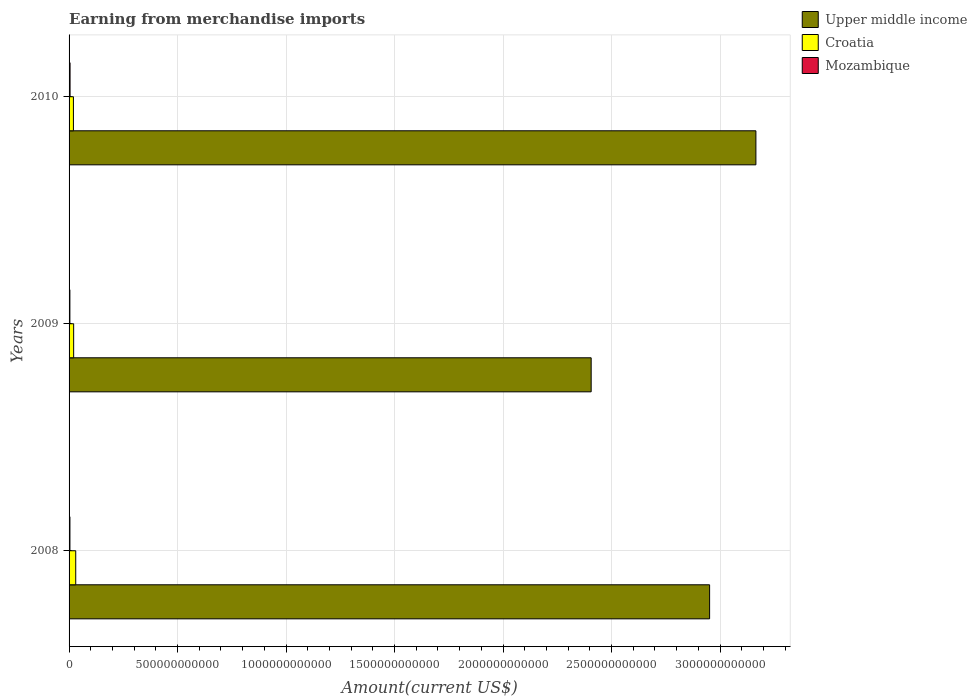How many bars are there on the 1st tick from the bottom?
Your answer should be very brief. 3. What is the amount earned from merchandise imports in Upper middle income in 2008?
Provide a succinct answer. 2.95e+12. Across all years, what is the maximum amount earned from merchandise imports in Mozambique?
Keep it short and to the point. 4.60e+09. Across all years, what is the minimum amount earned from merchandise imports in Upper middle income?
Ensure brevity in your answer.  2.41e+12. In which year was the amount earned from merchandise imports in Mozambique minimum?
Offer a very short reply. 2009. What is the total amount earned from merchandise imports in Croatia in the graph?
Offer a very short reply. 7.19e+1. What is the difference between the amount earned from merchandise imports in Upper middle income in 2008 and that in 2009?
Keep it short and to the point. 5.46e+11. What is the difference between the amount earned from merchandise imports in Upper middle income in 2010 and the amount earned from merchandise imports in Mozambique in 2008?
Offer a terse response. 3.16e+12. What is the average amount earned from merchandise imports in Croatia per year?
Provide a succinct answer. 2.40e+1. In the year 2010, what is the difference between the amount earned from merchandise imports in Upper middle income and amount earned from merchandise imports in Mozambique?
Keep it short and to the point. 3.16e+12. What is the ratio of the amount earned from merchandise imports in Upper middle income in 2008 to that in 2010?
Make the answer very short. 0.93. Is the amount earned from merchandise imports in Croatia in 2008 less than that in 2010?
Offer a terse response. No. What is the difference between the highest and the second highest amount earned from merchandise imports in Upper middle income?
Provide a short and direct response. 2.13e+11. What is the difference between the highest and the lowest amount earned from merchandise imports in Upper middle income?
Keep it short and to the point. 7.59e+11. In how many years, is the amount earned from merchandise imports in Croatia greater than the average amount earned from merchandise imports in Croatia taken over all years?
Offer a terse response. 1. What does the 1st bar from the top in 2009 represents?
Give a very brief answer. Mozambique. What does the 2nd bar from the bottom in 2010 represents?
Offer a very short reply. Croatia. Are all the bars in the graph horizontal?
Your response must be concise. Yes. How many years are there in the graph?
Provide a short and direct response. 3. What is the difference between two consecutive major ticks on the X-axis?
Give a very brief answer. 5.00e+11. Does the graph contain any zero values?
Provide a short and direct response. No. Does the graph contain grids?
Your response must be concise. Yes. Where does the legend appear in the graph?
Your answer should be very brief. Top right. How many legend labels are there?
Offer a terse response. 3. How are the legend labels stacked?
Your answer should be compact. Vertical. What is the title of the graph?
Make the answer very short. Earning from merchandise imports. Does "Channel Islands" appear as one of the legend labels in the graph?
Provide a short and direct response. No. What is the label or title of the X-axis?
Your answer should be compact. Amount(current US$). What is the Amount(current US$) of Upper middle income in 2008?
Ensure brevity in your answer.  2.95e+12. What is the Amount(current US$) in Croatia in 2008?
Provide a succinct answer. 3.07e+1. What is the Amount(current US$) in Mozambique in 2008?
Provide a succinct answer. 4.01e+09. What is the Amount(current US$) in Upper middle income in 2009?
Give a very brief answer. 2.41e+12. What is the Amount(current US$) in Croatia in 2009?
Your response must be concise. 2.11e+1. What is the Amount(current US$) of Mozambique in 2009?
Your answer should be very brief. 3.76e+09. What is the Amount(current US$) in Upper middle income in 2010?
Give a very brief answer. 3.17e+12. What is the Amount(current US$) of Croatia in 2010?
Your response must be concise. 2.01e+1. What is the Amount(current US$) in Mozambique in 2010?
Offer a terse response. 4.60e+09. Across all years, what is the maximum Amount(current US$) of Upper middle income?
Provide a succinct answer. 3.17e+12. Across all years, what is the maximum Amount(current US$) of Croatia?
Your answer should be compact. 3.07e+1. Across all years, what is the maximum Amount(current US$) in Mozambique?
Offer a very short reply. 4.60e+09. Across all years, what is the minimum Amount(current US$) of Upper middle income?
Ensure brevity in your answer.  2.41e+12. Across all years, what is the minimum Amount(current US$) of Croatia?
Offer a terse response. 2.01e+1. Across all years, what is the minimum Amount(current US$) of Mozambique?
Offer a terse response. 3.76e+09. What is the total Amount(current US$) of Upper middle income in the graph?
Your answer should be very brief. 8.52e+12. What is the total Amount(current US$) of Croatia in the graph?
Give a very brief answer. 7.19e+1. What is the total Amount(current US$) in Mozambique in the graph?
Provide a succinct answer. 1.24e+1. What is the difference between the Amount(current US$) in Upper middle income in 2008 and that in 2009?
Your response must be concise. 5.46e+11. What is the difference between the Amount(current US$) of Croatia in 2008 and that in 2009?
Make the answer very short. 9.61e+09. What is the difference between the Amount(current US$) of Mozambique in 2008 and that in 2009?
Make the answer very short. 2.44e+08. What is the difference between the Amount(current US$) in Upper middle income in 2008 and that in 2010?
Your answer should be very brief. -2.13e+11. What is the difference between the Amount(current US$) in Croatia in 2008 and that in 2010?
Your answer should be very brief. 1.07e+1. What is the difference between the Amount(current US$) of Mozambique in 2008 and that in 2010?
Your answer should be very brief. -5.92e+08. What is the difference between the Amount(current US$) of Upper middle income in 2009 and that in 2010?
Your answer should be compact. -7.59e+11. What is the difference between the Amount(current US$) in Croatia in 2009 and that in 2010?
Keep it short and to the point. 1.06e+09. What is the difference between the Amount(current US$) of Mozambique in 2009 and that in 2010?
Give a very brief answer. -8.36e+08. What is the difference between the Amount(current US$) of Upper middle income in 2008 and the Amount(current US$) of Croatia in 2009?
Provide a short and direct response. 2.93e+12. What is the difference between the Amount(current US$) of Upper middle income in 2008 and the Amount(current US$) of Mozambique in 2009?
Provide a succinct answer. 2.95e+12. What is the difference between the Amount(current US$) in Croatia in 2008 and the Amount(current US$) in Mozambique in 2009?
Your response must be concise. 2.70e+1. What is the difference between the Amount(current US$) in Upper middle income in 2008 and the Amount(current US$) in Croatia in 2010?
Provide a short and direct response. 2.93e+12. What is the difference between the Amount(current US$) in Upper middle income in 2008 and the Amount(current US$) in Mozambique in 2010?
Your response must be concise. 2.95e+12. What is the difference between the Amount(current US$) of Croatia in 2008 and the Amount(current US$) of Mozambique in 2010?
Give a very brief answer. 2.61e+1. What is the difference between the Amount(current US$) in Upper middle income in 2009 and the Amount(current US$) in Croatia in 2010?
Provide a short and direct response. 2.39e+12. What is the difference between the Amount(current US$) in Upper middle income in 2009 and the Amount(current US$) in Mozambique in 2010?
Offer a terse response. 2.40e+12. What is the difference between the Amount(current US$) in Croatia in 2009 and the Amount(current US$) in Mozambique in 2010?
Ensure brevity in your answer.  1.65e+1. What is the average Amount(current US$) of Upper middle income per year?
Give a very brief answer. 2.84e+12. What is the average Amount(current US$) of Croatia per year?
Your answer should be very brief. 2.40e+1. What is the average Amount(current US$) of Mozambique per year?
Provide a short and direct response. 4.12e+09. In the year 2008, what is the difference between the Amount(current US$) of Upper middle income and Amount(current US$) of Croatia?
Your answer should be compact. 2.92e+12. In the year 2008, what is the difference between the Amount(current US$) of Upper middle income and Amount(current US$) of Mozambique?
Keep it short and to the point. 2.95e+12. In the year 2008, what is the difference between the Amount(current US$) of Croatia and Amount(current US$) of Mozambique?
Offer a very short reply. 2.67e+1. In the year 2009, what is the difference between the Amount(current US$) of Upper middle income and Amount(current US$) of Croatia?
Ensure brevity in your answer.  2.38e+12. In the year 2009, what is the difference between the Amount(current US$) in Upper middle income and Amount(current US$) in Mozambique?
Your answer should be compact. 2.40e+12. In the year 2009, what is the difference between the Amount(current US$) of Croatia and Amount(current US$) of Mozambique?
Offer a very short reply. 1.74e+1. In the year 2010, what is the difference between the Amount(current US$) of Upper middle income and Amount(current US$) of Croatia?
Provide a short and direct response. 3.15e+12. In the year 2010, what is the difference between the Amount(current US$) in Upper middle income and Amount(current US$) in Mozambique?
Your answer should be very brief. 3.16e+12. In the year 2010, what is the difference between the Amount(current US$) of Croatia and Amount(current US$) of Mozambique?
Give a very brief answer. 1.55e+1. What is the ratio of the Amount(current US$) in Upper middle income in 2008 to that in 2009?
Ensure brevity in your answer.  1.23. What is the ratio of the Amount(current US$) of Croatia in 2008 to that in 2009?
Your answer should be compact. 1.45. What is the ratio of the Amount(current US$) in Mozambique in 2008 to that in 2009?
Provide a short and direct response. 1.06. What is the ratio of the Amount(current US$) of Upper middle income in 2008 to that in 2010?
Your answer should be compact. 0.93. What is the ratio of the Amount(current US$) of Croatia in 2008 to that in 2010?
Provide a short and direct response. 1.53. What is the ratio of the Amount(current US$) in Mozambique in 2008 to that in 2010?
Your answer should be compact. 0.87. What is the ratio of the Amount(current US$) in Upper middle income in 2009 to that in 2010?
Offer a terse response. 0.76. What is the ratio of the Amount(current US$) of Croatia in 2009 to that in 2010?
Ensure brevity in your answer.  1.05. What is the ratio of the Amount(current US$) in Mozambique in 2009 to that in 2010?
Your response must be concise. 0.82. What is the difference between the highest and the second highest Amount(current US$) of Upper middle income?
Your response must be concise. 2.13e+11. What is the difference between the highest and the second highest Amount(current US$) in Croatia?
Your response must be concise. 9.61e+09. What is the difference between the highest and the second highest Amount(current US$) in Mozambique?
Keep it short and to the point. 5.92e+08. What is the difference between the highest and the lowest Amount(current US$) of Upper middle income?
Offer a terse response. 7.59e+11. What is the difference between the highest and the lowest Amount(current US$) of Croatia?
Your response must be concise. 1.07e+1. What is the difference between the highest and the lowest Amount(current US$) in Mozambique?
Ensure brevity in your answer.  8.36e+08. 